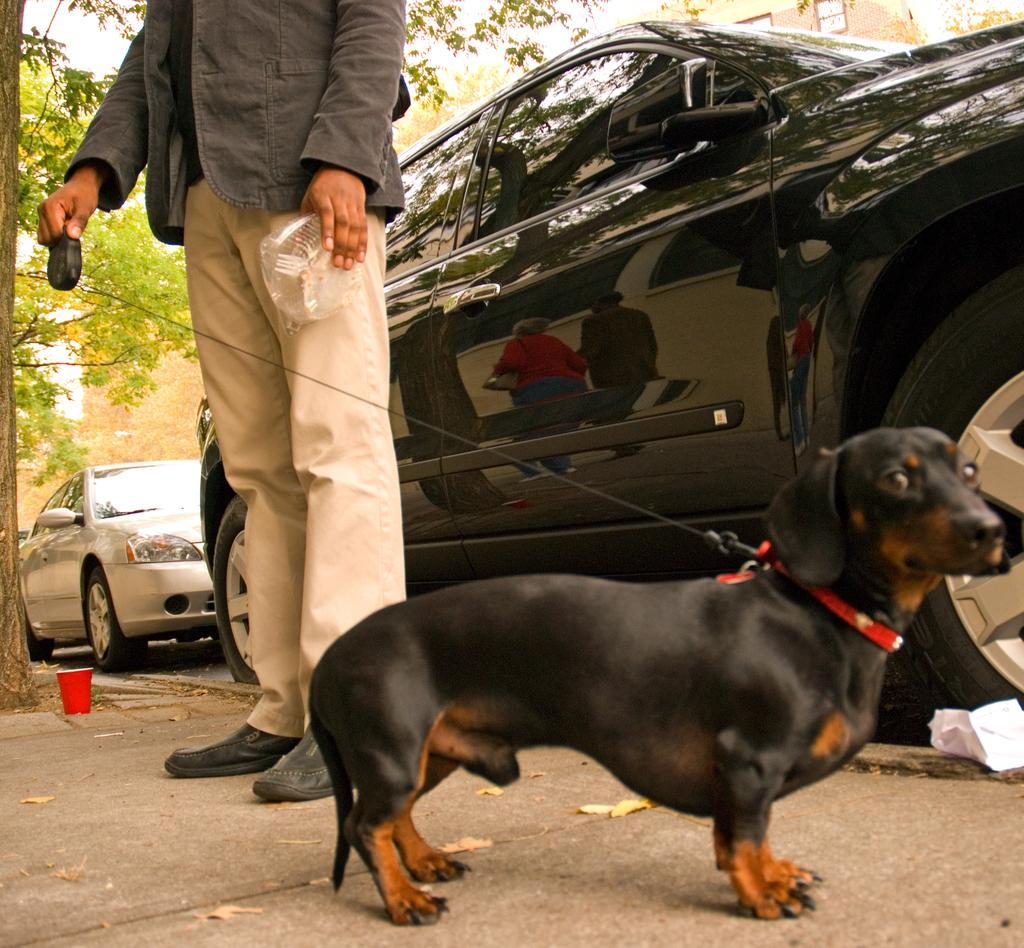What type of animal is in the image? There is a black dog in the image. Where is the dog located? The dog is standing on the road. What is the man in the image doing? The man is attempting to catch the dog with a wire. What can be seen in the background of the image? There are two cars in the background of the image. How many horses are present in the image? There are no horses present in the image; it features a black dog and a man with a wire. What type of servant is attending to the dog in the image? There is no servant present in the image; it is a man attempting to catch the dog with a wire. 